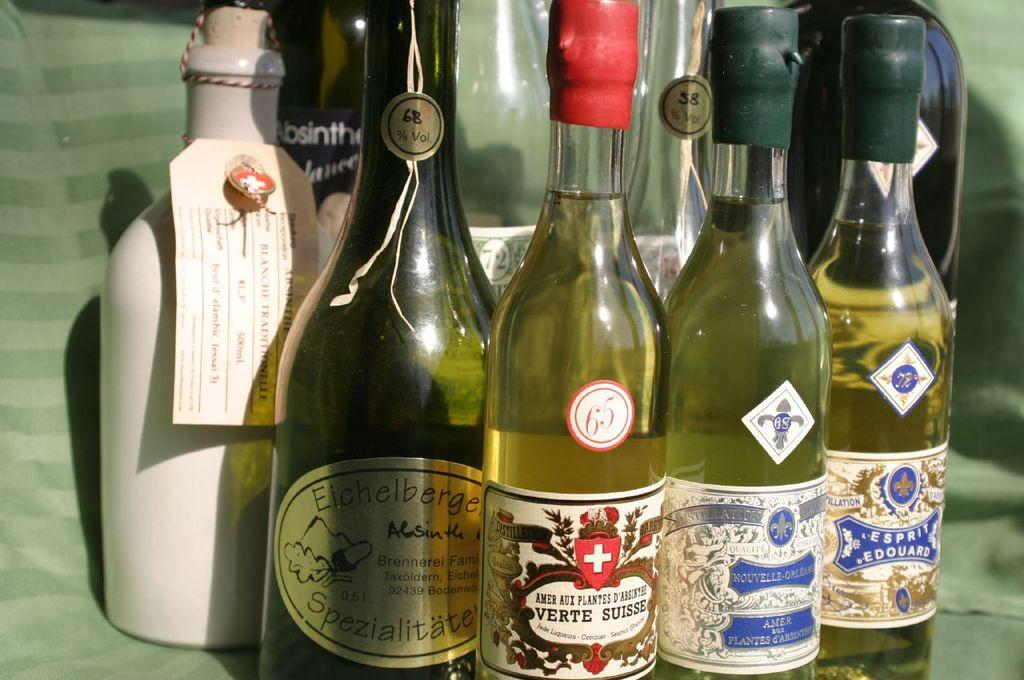Provide a one-sentence caption for the provided image. A varied collection of liquor offerings have different alcohol percentages, like 68% and 58%. 